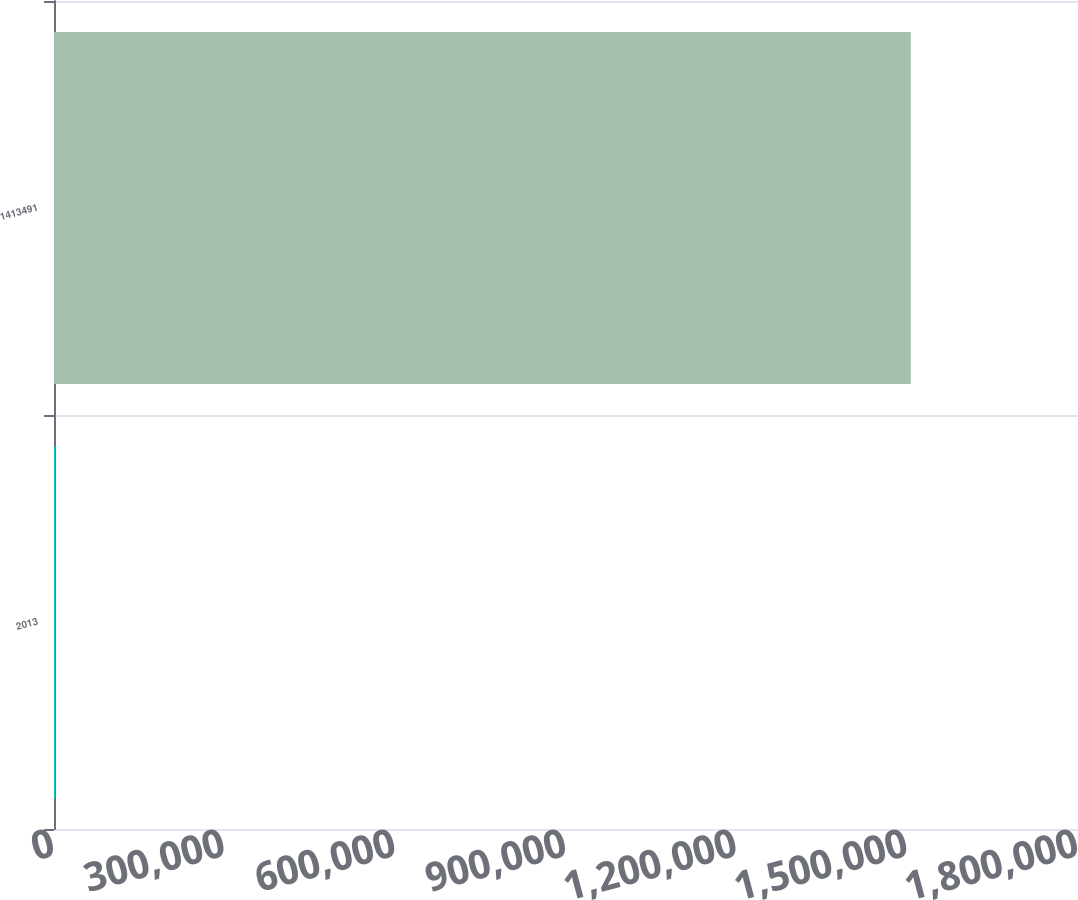Convert chart to OTSL. <chart><loc_0><loc_0><loc_500><loc_500><bar_chart><fcel>2013<fcel>1413491<nl><fcel>2012<fcel>1.50615e+06<nl></chart> 